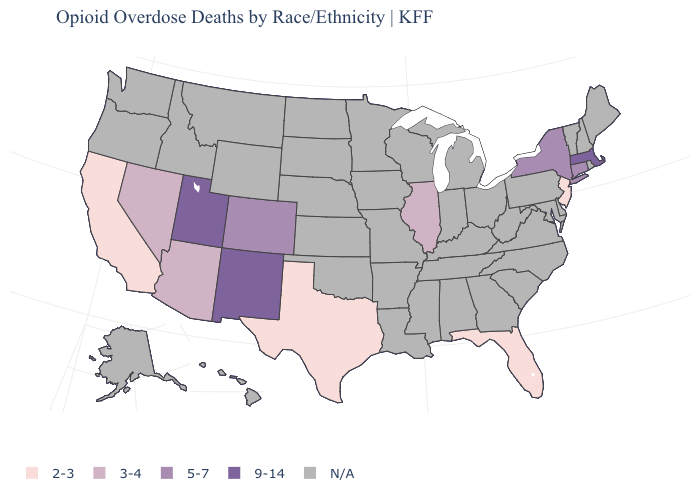Which states have the lowest value in the West?
Short answer required. California. Name the states that have a value in the range 5-7?
Quick response, please. Colorado, Connecticut, New York. What is the lowest value in the USA?
Concise answer only. 2-3. What is the value of New York?
Short answer required. 5-7. Which states have the lowest value in the MidWest?
Keep it brief. Illinois. Which states have the lowest value in the South?
Answer briefly. Florida, Texas. What is the lowest value in the South?
Concise answer only. 2-3. What is the lowest value in the Northeast?
Concise answer only. 2-3. How many symbols are there in the legend?
Short answer required. 5. What is the value of Missouri?
Write a very short answer. N/A. Name the states that have a value in the range 2-3?
Short answer required. California, Florida, New Jersey, Texas. Which states have the highest value in the USA?
Be succinct. Massachusetts, New Mexico, Utah. What is the lowest value in the USA?
Quick response, please. 2-3. 